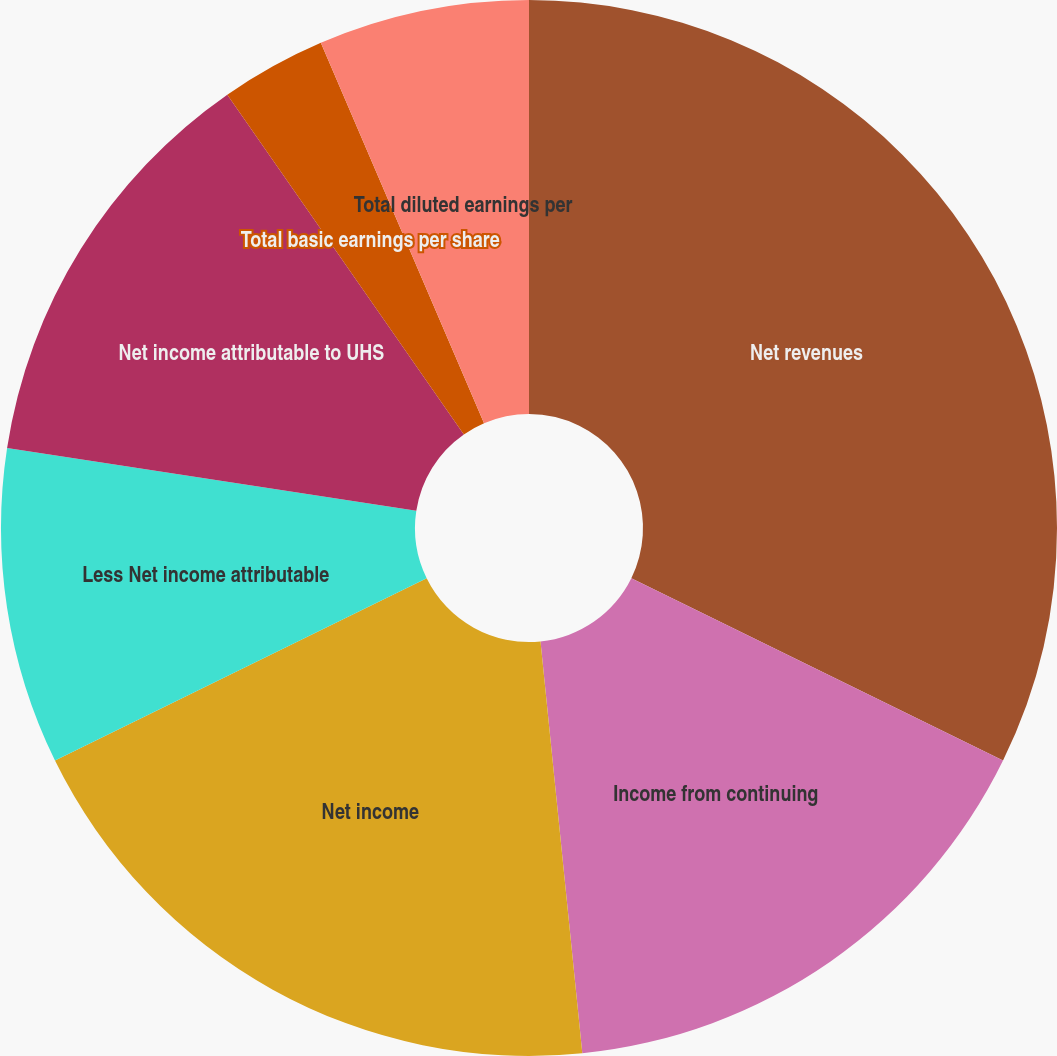<chart> <loc_0><loc_0><loc_500><loc_500><pie_chart><fcel>Net revenues<fcel>Income from continuing<fcel>Net income<fcel>Less Net income attributable<fcel>Net income attributable to UHS<fcel>From continuing operations<fcel>Total basic earnings per share<fcel>Total diluted earnings per<nl><fcel>32.26%<fcel>16.13%<fcel>19.35%<fcel>9.68%<fcel>12.9%<fcel>0.0%<fcel>3.23%<fcel>6.45%<nl></chart> 